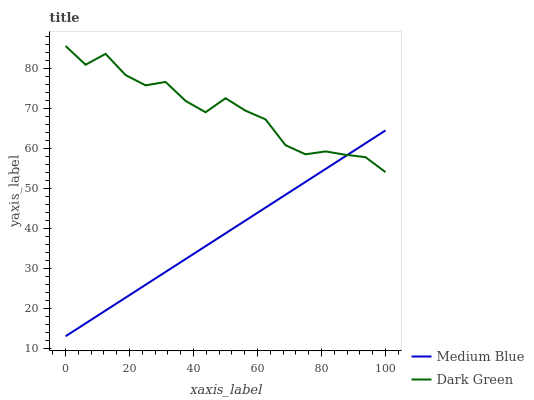Does Medium Blue have the minimum area under the curve?
Answer yes or no. Yes. Does Dark Green have the maximum area under the curve?
Answer yes or no. Yes. Does Dark Green have the minimum area under the curve?
Answer yes or no. No. Is Medium Blue the smoothest?
Answer yes or no. Yes. Is Dark Green the roughest?
Answer yes or no. Yes. Is Dark Green the smoothest?
Answer yes or no. No. Does Medium Blue have the lowest value?
Answer yes or no. Yes. Does Dark Green have the lowest value?
Answer yes or no. No. Does Dark Green have the highest value?
Answer yes or no. Yes. Does Medium Blue intersect Dark Green?
Answer yes or no. Yes. Is Medium Blue less than Dark Green?
Answer yes or no. No. Is Medium Blue greater than Dark Green?
Answer yes or no. No. 